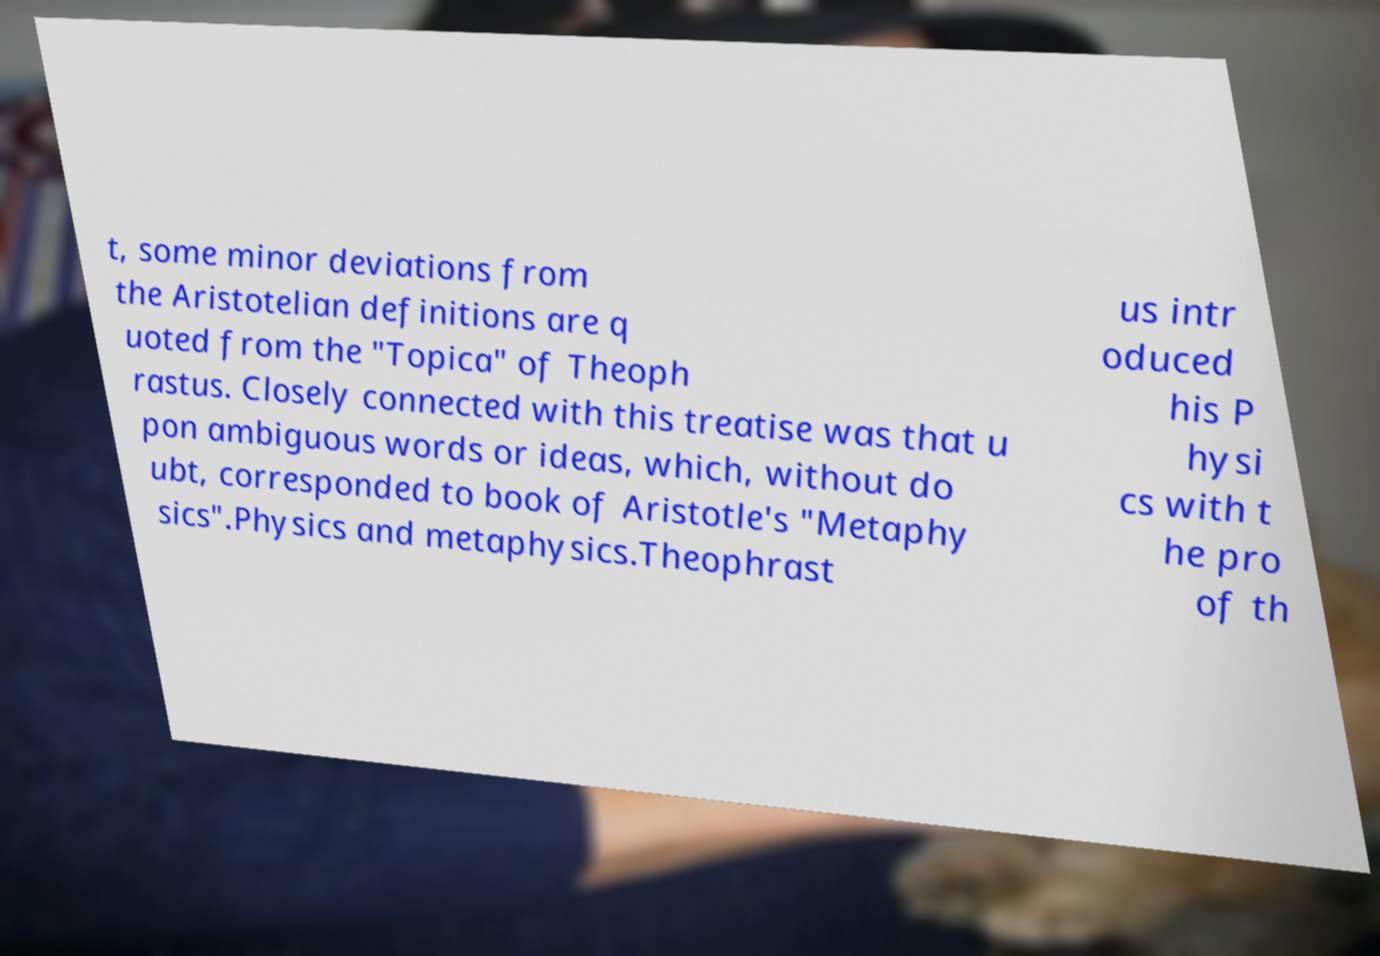What messages or text are displayed in this image? I need them in a readable, typed format. t, some minor deviations from the Aristotelian definitions are q uoted from the "Topica" of Theoph rastus. Closely connected with this treatise was that u pon ambiguous words or ideas, which, without do ubt, corresponded to book of Aristotle's "Metaphy sics".Physics and metaphysics.Theophrast us intr oduced his P hysi cs with t he pro of th 